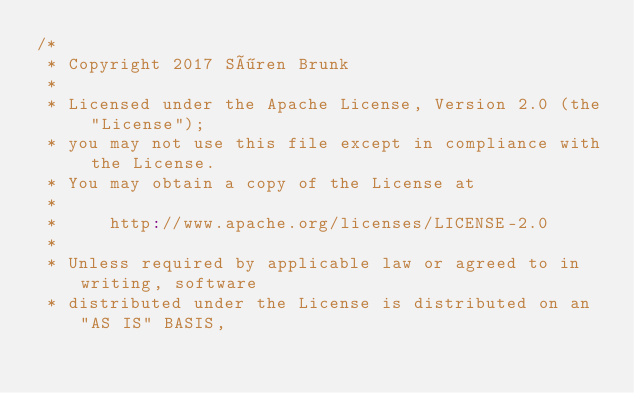<code> <loc_0><loc_0><loc_500><loc_500><_Scala_>/*
 * Copyright 2017 Sören Brunk
 *
 * Licensed under the Apache License, Version 2.0 (the "License");
 * you may not use this file except in compliance with the License.
 * You may obtain a copy of the License at
 *
 *     http://www.apache.org/licenses/LICENSE-2.0
 *
 * Unless required by applicable law or agreed to in writing, software
 * distributed under the License is distributed on an "AS IS" BASIS,</code> 